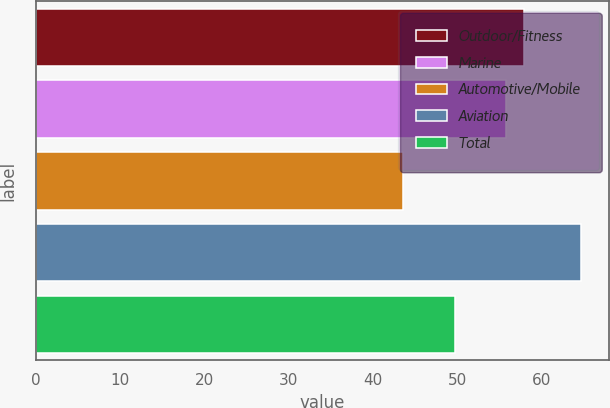<chart> <loc_0><loc_0><loc_500><loc_500><bar_chart><fcel>Outdoor/Fitness<fcel>Marine<fcel>Automotive/Mobile<fcel>Aviation<fcel>Total<nl><fcel>57.91<fcel>55.8<fcel>43.6<fcel>64.7<fcel>49.7<nl></chart> 